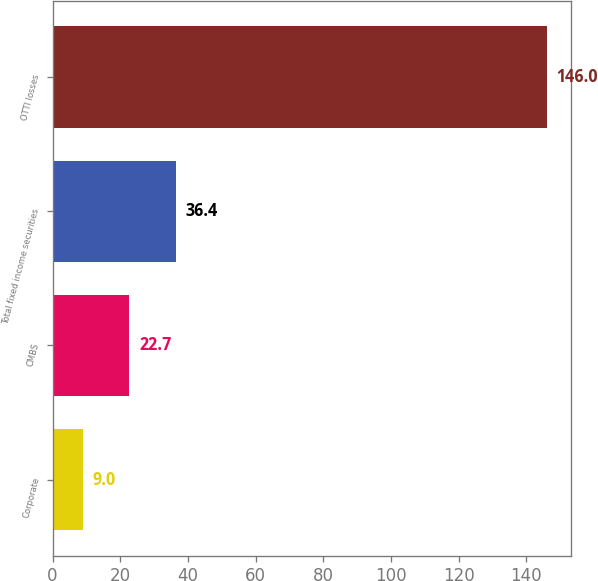Convert chart to OTSL. <chart><loc_0><loc_0><loc_500><loc_500><bar_chart><fcel>Corporate<fcel>CMBS<fcel>Total fixed income securities<fcel>OTTI losses<nl><fcel>9<fcel>22.7<fcel>36.4<fcel>146<nl></chart> 